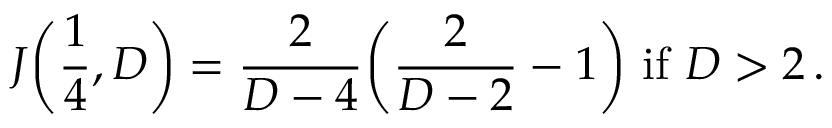<formula> <loc_0><loc_0><loc_500><loc_500>J \left ( \frac { 1 } { 4 } , D \right ) = \frac { 2 } { D - 4 } \left ( \frac { 2 } { D - 2 } - 1 \right ) \, i f \, D > 2 \, .</formula> 